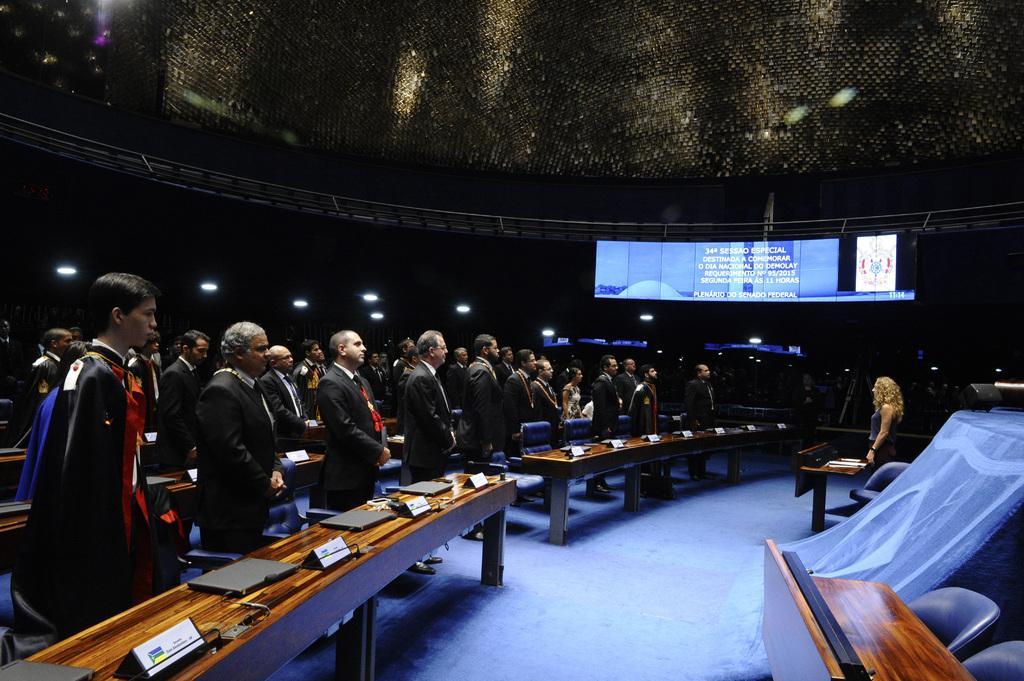In one or two sentences, can you explain what this image depicts? In this image, there are people standing on the left side and at the bottom right hand corner there is a table. 